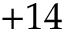<formula> <loc_0><loc_0><loc_500><loc_500>+ 1 4</formula> 